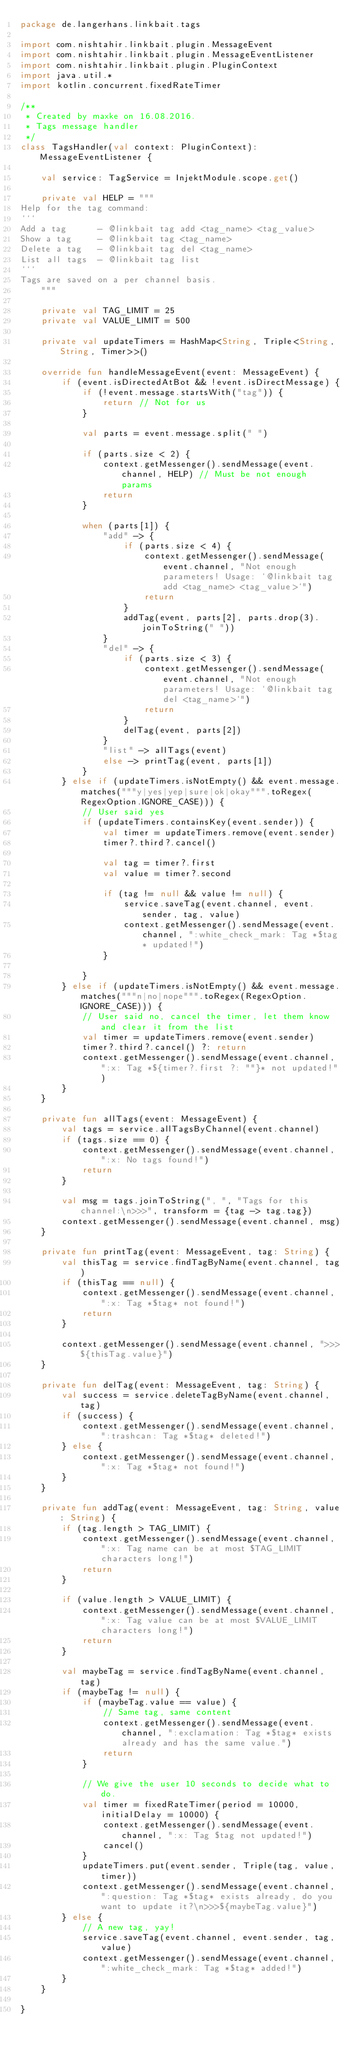<code> <loc_0><loc_0><loc_500><loc_500><_Kotlin_>package de.langerhans.linkbait.tags

import com.nishtahir.linkbait.plugin.MessageEvent
import com.nishtahir.linkbait.plugin.MessageEventListener
import com.nishtahir.linkbait.plugin.PluginContext
import java.util.*
import kotlin.concurrent.fixedRateTimer

/**
 * Created by maxke on 16.08.2016.
 * Tags message handler
 */
class TagsHandler(val context: PluginContext): MessageEventListener {

    val service: TagService = InjektModule.scope.get()

    private val HELP = """
Help for the tag command:
```
Add a tag      - @linkbait tag add <tag_name> <tag_value>
Show a tag     - @linkbait tag <tag_name>
Delete a tag   - @linkbait tag del <tag_name>
List all tags  - @linkbait tag list
```
Tags are saved on a per channel basis.
    """

    private val TAG_LIMIT = 25
    private val VALUE_LIMIT = 500

    private val updateTimers = HashMap<String, Triple<String, String, Timer>>()

    override fun handleMessageEvent(event: MessageEvent) {
        if (event.isDirectedAtBot && !event.isDirectMessage) {
            if (!event.message.startsWith("tag")) {
                return // Not for us
            }

            val parts = event.message.split(" ")

            if (parts.size < 2) {
                context.getMessenger().sendMessage(event.channel, HELP) // Must be not enough params
                return
            }

            when (parts[1]) {
                "add" -> {
                    if (parts.size < 4) {
                        context.getMessenger().sendMessage(event.channel, "Not enough parameters! Usage: `@linkbait tag add <tag_name> <tag_value>`")
                        return
                    }
                    addTag(event, parts[2], parts.drop(3).joinToString(" "))
                }
                "del" -> {
                    if (parts.size < 3) {
                        context.getMessenger().sendMessage(event.channel, "Not enough parameters! Usage: `@linkbait tag del <tag_name>`")
                        return
                    }
                    delTag(event, parts[2])
                }
                "list" -> allTags(event)
                else -> printTag(event, parts[1])
            }
        } else if (updateTimers.isNotEmpty() && event.message.matches("""y|yes|yep|sure|ok|okay""".toRegex(RegexOption.IGNORE_CASE))) {
            // User said yes
            if (updateTimers.containsKey(event.sender)) {
                val timer = updateTimers.remove(event.sender)
                timer?.third?.cancel()

                val tag = timer?.first
                val value = timer?.second

                if (tag != null && value != null) {
                    service.saveTag(event.channel, event.sender, tag, value)
                    context.getMessenger().sendMessage(event.channel, ":white_check_mark: Tag *$tag* updated!")
                }

            }
        } else if (updateTimers.isNotEmpty() && event.message.matches("""n|no|nope""".toRegex(RegexOption.IGNORE_CASE))) {
            // User said no, cancel the timer, let them know and clear it from the list
            val timer = updateTimers.remove(event.sender)
            timer?.third?.cancel() ?: return
            context.getMessenger().sendMessage(event.channel, ":x: Tag *${timer?.first ?: ""}* not updated!")
        }
    }

    private fun allTags(event: MessageEvent) {
        val tags = service.allTagsByChannel(event.channel)
        if (tags.size == 0) {
            context.getMessenger().sendMessage(event.channel, ":x: No tags found!")
            return
        }

        val msg = tags.joinToString(", ", "Tags for this channel:\n>>>", transform = {tag -> tag.tag})
        context.getMessenger().sendMessage(event.channel, msg)
    }

    private fun printTag(event: MessageEvent, tag: String) {
        val thisTag = service.findTagByName(event.channel, tag)
        if (thisTag == null) {
            context.getMessenger().sendMessage(event.channel, ":x: Tag *$tag* not found!")
            return
        }

        context.getMessenger().sendMessage(event.channel, ">>>${thisTag.value}")
    }

    private fun delTag(event: MessageEvent, tag: String) {
        val success = service.deleteTagByName(event.channel, tag)
        if (success) {
            context.getMessenger().sendMessage(event.channel, ":trashcan: Tag *$tag* deleted!")
        } else {
            context.getMessenger().sendMessage(event.channel, ":x: Tag *$tag* not found!")
        }
    }

    private fun addTag(event: MessageEvent, tag: String, value: String) {
        if (tag.length > TAG_LIMIT) {
            context.getMessenger().sendMessage(event.channel, ":x: Tag name can be at most $TAG_LIMIT characters long!")
            return
        }

        if (value.length > VALUE_LIMIT) {
            context.getMessenger().sendMessage(event.channel, ":x: Tag value can be at most $VALUE_LIMIT characters long!")
            return
        }

        val maybeTag = service.findTagByName(event.channel, tag)
        if (maybeTag != null) {
            if (maybeTag.value == value) {
                // Same tag, same content
                context.getMessenger().sendMessage(event.channel, ":exclamation: Tag *$tag* exists already and has the same value.")
                return
            }

            // We give the user 10 seconds to decide what to do.
            val timer = fixedRateTimer(period = 10000, initialDelay = 10000) {
                context.getMessenger().sendMessage(event.channel, ":x: Tag $tag not updated!")
                cancel()
            }
            updateTimers.put(event.sender, Triple(tag, value, timer))
            context.getMessenger().sendMessage(event.channel, ":question: Tag *$tag* exists already, do you want to update it?\n>>>${maybeTag.value}")
        } else {
            // A new tag, yay!
            service.saveTag(event.channel, event.sender, tag, value)
            context.getMessenger().sendMessage(event.channel, ":white_check_mark: Tag *$tag* added!")
        }
    }

}</code> 